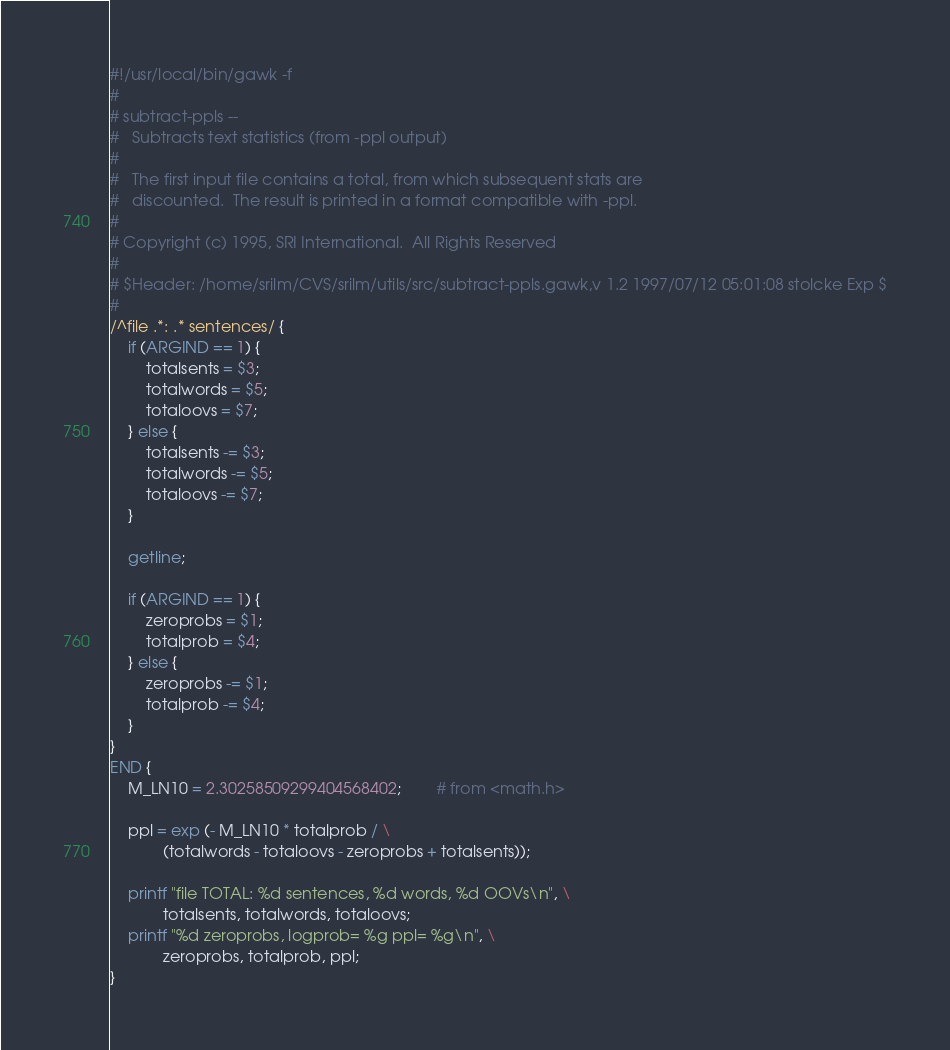Convert code to text. <code><loc_0><loc_0><loc_500><loc_500><_Awk_>#!/usr/local/bin/gawk -f
#
# subtract-ppls --
#	Subtracts text statistics (from -ppl output)
#
#	The first input file contains a total, from which subsequent stats are
#	discounted.  The result is printed in a format compatible with -ppl.
#
# Copyright (c) 1995, SRI International.  All Rights Reserved
#
# $Header: /home/srilm/CVS/srilm/utils/src/subtract-ppls.gawk,v 1.2 1997/07/12 05:01:08 stolcke Exp $
#
/^file .*: .* sentences/ {
	if (ARGIND == 1) {
		totalsents = $3;
		totalwords = $5;
		totaloovs = $7;
	} else {
		totalsents -= $3;
		totalwords -= $5;
		totaloovs -= $7;
	}

	getline;

	if (ARGIND == 1) {
		zeroprobs = $1;
		totalprob = $4;
	} else {
		zeroprobs -= $1;
		totalprob -= $4;
	}
}
END {
	M_LN10 = 2.30258509299404568402;        # from <math.h>

	ppl = exp (- M_LN10 * totalprob / \
			(totalwords - totaloovs - zeroprobs + totalsents));

	printf "file TOTAL: %d sentences, %d words, %d OOVs\n", \
			totalsents, totalwords, totaloovs;
	printf "%d zeroprobs, logprob= %g ppl= %g\n", \
			zeroprobs, totalprob, ppl;
}
</code> 